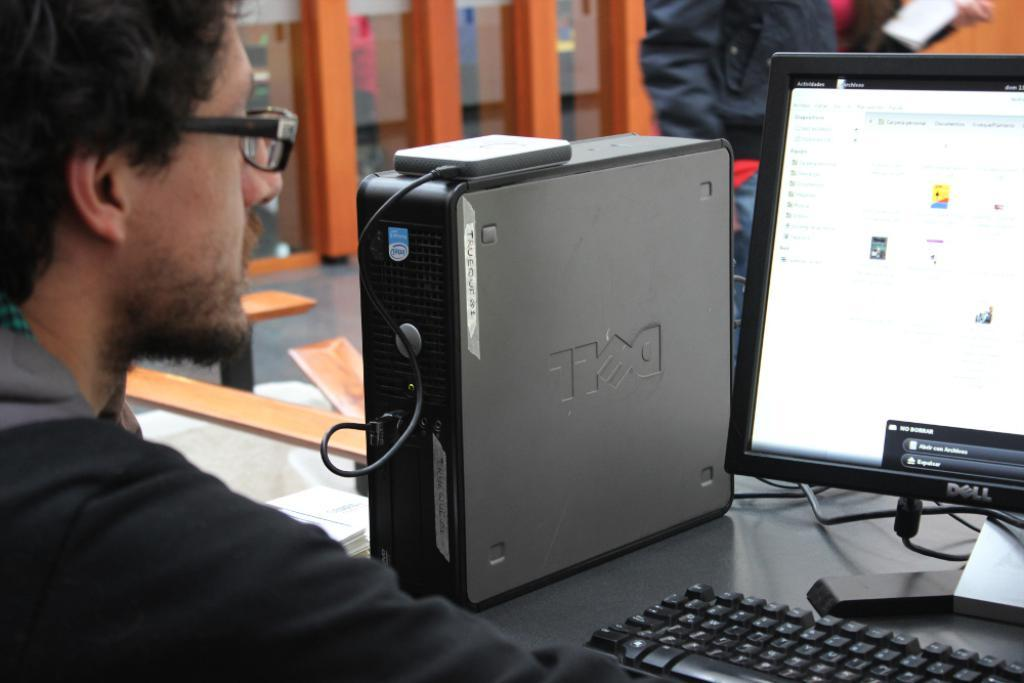Provide a one-sentence caption for the provided image. A man wearing glasses sits at a long table in front of a Dell computer and monitor. 